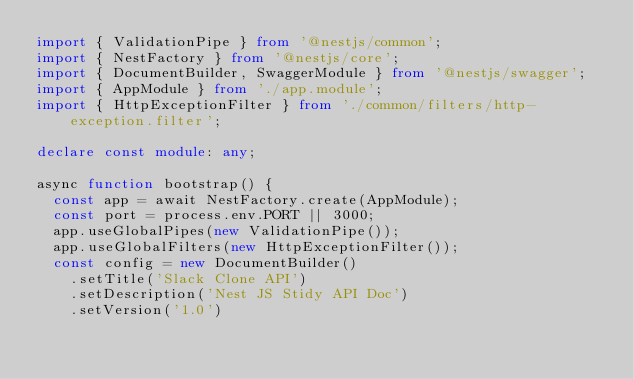Convert code to text. <code><loc_0><loc_0><loc_500><loc_500><_TypeScript_>import { ValidationPipe } from '@nestjs/common';
import { NestFactory } from '@nestjs/core';
import { DocumentBuilder, SwaggerModule } from '@nestjs/swagger';
import { AppModule } from './app.module';
import { HttpExceptionFilter } from './common/filters/http-exception.filter';

declare const module: any;

async function bootstrap() {
  const app = await NestFactory.create(AppModule);
  const port = process.env.PORT || 3000;
  app.useGlobalPipes(new ValidationPipe());
  app.useGlobalFilters(new HttpExceptionFilter());
  const config = new DocumentBuilder()
    .setTitle('Slack Clone API')
    .setDescription('Nest JS Stidy API Doc')
    .setVersion('1.0')</code> 